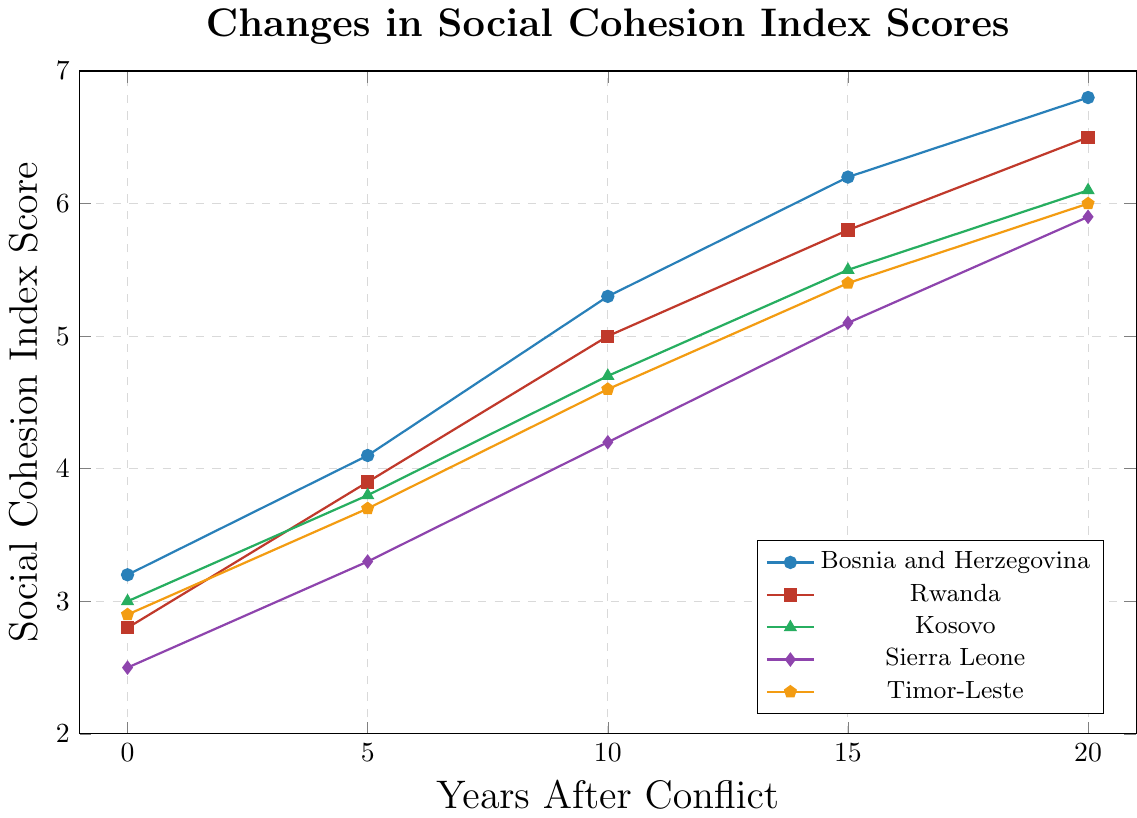what is the average social cohesion index score for Rwanda over the 20-year period? To find the average, add up all of Rwanda's scores and then divide by the number of scores. The scores are 2.8, 3.9, 5.0, 5.8, and 6.5. Therefore, the sum is 2.8 + 3.9 + 5.0 + 5.8 + 6.5 = 24. The number of scores is 5, so the average is 24/5 = 4.8
Answer: 4.8 How much has the social cohesion index score for Kosovo increased from Year 0 to Year 20? Look at Kosovo's scores at Year 0 and Year 20, which are 3.0 and 6.1, respectively. Subtract the Year 0 value from the Year 20 value: 6.1 - 3.0 = 3.1
Answer: 3.1 Which region shows the smallest improvement in social cohesion index score over the 20-year period? To find this, calculate the difference between Year 20 and Year 0 scores for each region and compare them. The differences are as follows:
- Bosnia and Herzegovina: 6.8 - 3.2 = 3.6
- Rwanda: 6.5 - 2.8 = 3.7
- Kosovo: 6.1 - 3.0 = 3.1
- Sierra Leone: 5.9 - 2.5 = 3.4
- Timor-Leste: 6.0 - 2.9 = 3.1
- Liberia: 5.7 - 2.3 = 3.4
- Northern Ireland: 6.9 - 4.2 = 2.7
- Sri Lanka: 6.4 - 3.5 = 2.9
- Colombia: 6.6 - 3.7 = 2.9
- South Sudan: 5.3 - 2.1 = 3.2
Northern Ireland has the smallest improvement at 2.7
Answer: Northern Ireland What is the difference in social cohesion index score between Bosnia and Herzegovina and Liberia in Year 15? Find the scores for Bosnia and Herzegovina and Liberia in Year 15, which are 6.2 and 4.9, respectively. Subtract Liberia's score from Bosnia and Herzegovina's: 6.2 - 4.9 = 1.3
Answer: 1.3 Which region had the highest social cohesion index score in Year 0? Identify Year 0 scores and find the highest one: 
- Bosnia and Herzegovina: 3.2
- Rwanda: 2.8
- Kosovo: 3.0
- Sierra Leone: 2.5
- Timor-Leste: 2.9
- Liberia: 2.3
- Northern Ireland: 4.2
- Sri Lanka: 3.5
- Colombia: 3.7
- South Sudan: 2.1
Northern Ireland has the highest score at 4.2
Answer: Northern Ireland Between which years does Sierra Leone show the greatest increase in the social cohesion index score? Examine the increases between consecutive years for Sierra Leone: 
- Year 0 to Year 5: 3.3 - 2.5 = 0.8
- Year 5 to Year 10: 4.2 - 3.3 = 0.9
- Year 10 to Year 15: 5.1 - 4.2 = 0.9
- Year 15 to Year 20: 5.9 - 5.1 = 0.8
The greatest increases are both from Year 5 to Year 10 and Year 10 to Year 15, each at 0.9
Answer: Year 5 to Year 10 and Year 10 to Year 15 How many regions have a social cohesion index score greater than or equal to 6 in Year 20? Compare each region's Year 20 score to 6: 
- Bosnia and Herzegovina: 6.8 (>= 6)
- Rwanda: 6.5 (>= 6)
- Kosovo: 6.1 (>= 6)
- Sierra Leone: 5.9 (< 6)
- Timor-Leste: 6.0 (>= 6)
- Liberia: 5.7 (< 6)
- Northern Ireland: 6.9 (>= 6)
- Sri Lanka: 6.4 (>= 6)
- Colombia: 6.6 (>= 6)
- South Sudan: 5.3 (< 6)
7 regions meet this criterion
Answer: 7 